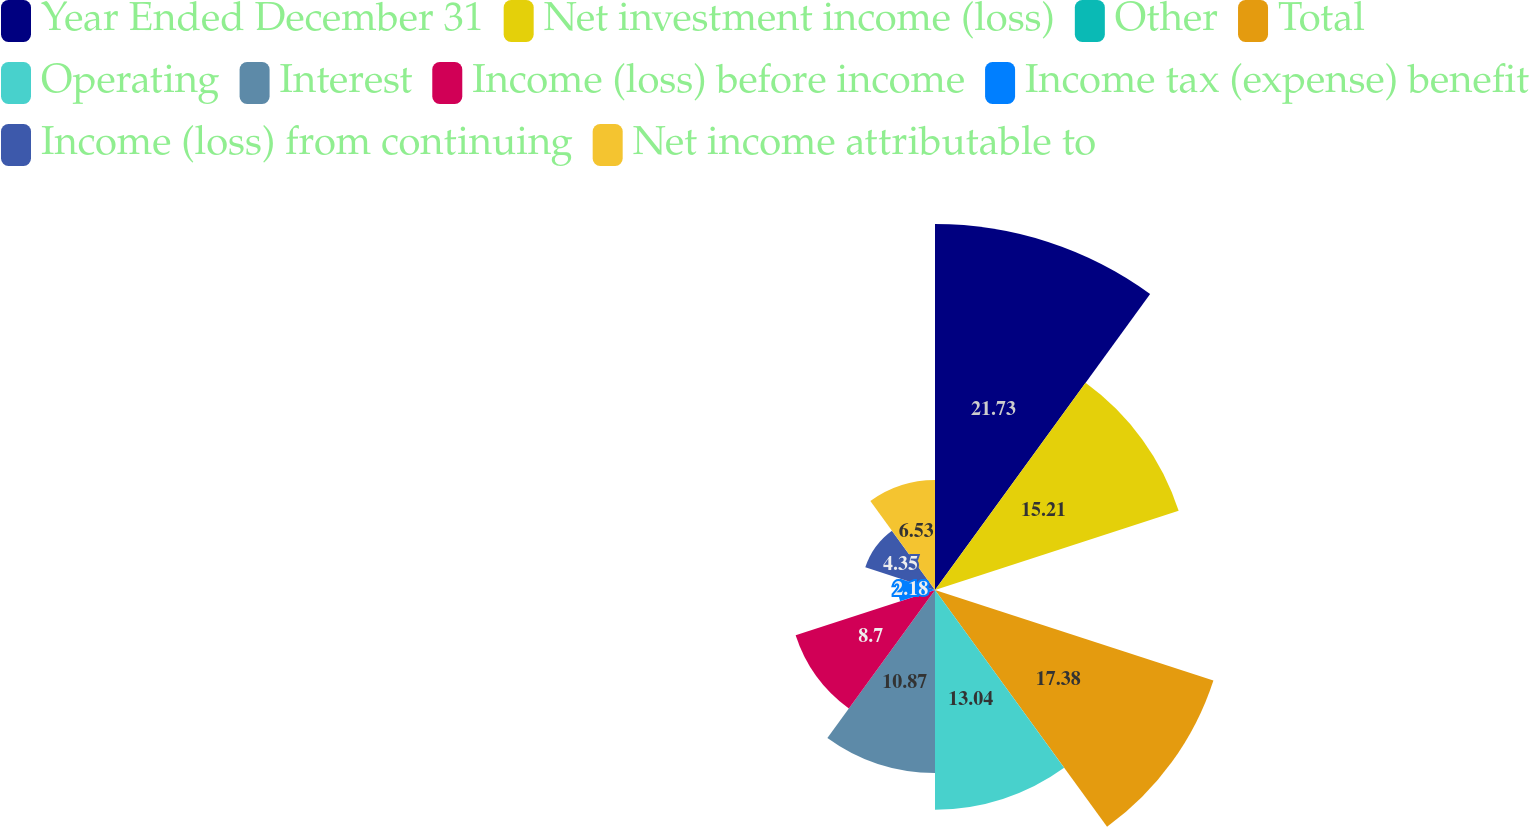Convert chart. <chart><loc_0><loc_0><loc_500><loc_500><pie_chart><fcel>Year Ended December 31<fcel>Net investment income (loss)<fcel>Other<fcel>Total<fcel>Operating<fcel>Interest<fcel>Income (loss) before income<fcel>Income tax (expense) benefit<fcel>Income (loss) from continuing<fcel>Net income attributable to<nl><fcel>21.73%<fcel>15.21%<fcel>0.01%<fcel>17.38%<fcel>13.04%<fcel>10.87%<fcel>8.7%<fcel>2.18%<fcel>4.35%<fcel>6.53%<nl></chart> 